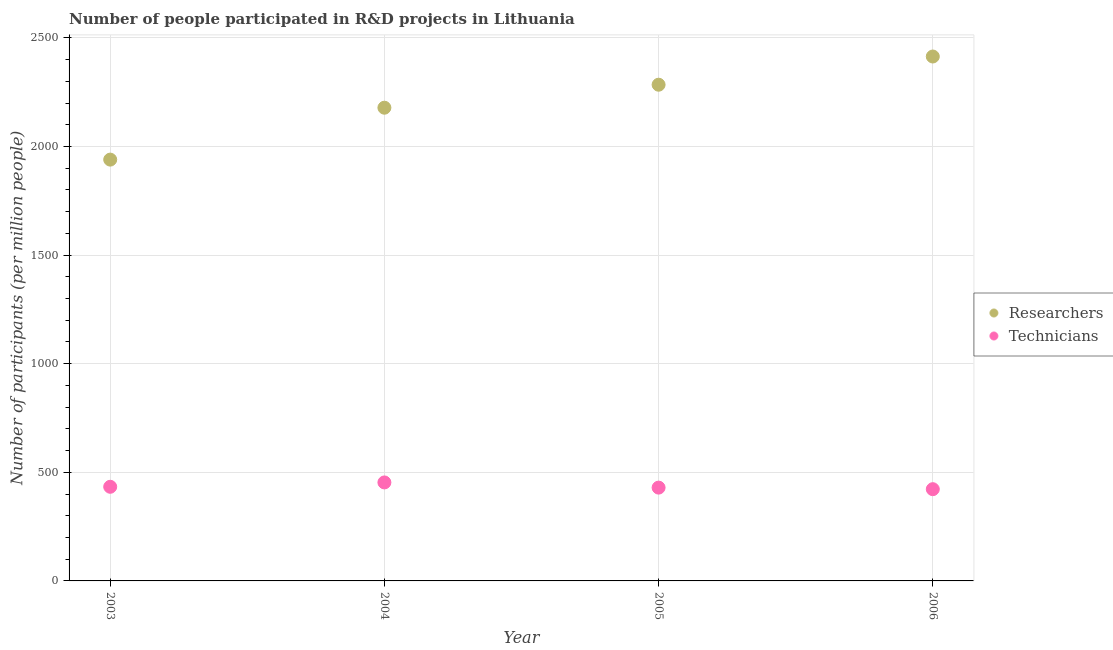How many different coloured dotlines are there?
Ensure brevity in your answer.  2. Is the number of dotlines equal to the number of legend labels?
Make the answer very short. Yes. What is the number of researchers in 2004?
Your answer should be compact. 2178.42. Across all years, what is the maximum number of technicians?
Provide a succinct answer. 453.39. Across all years, what is the minimum number of technicians?
Offer a terse response. 422.32. In which year was the number of technicians minimum?
Ensure brevity in your answer.  2006. What is the total number of technicians in the graph?
Offer a terse response. 1738.58. What is the difference between the number of technicians in 2004 and that in 2005?
Offer a terse response. 23.87. What is the difference between the number of technicians in 2006 and the number of researchers in 2005?
Your answer should be very brief. -1861.97. What is the average number of researchers per year?
Give a very brief answer. 2204.09. In the year 2006, what is the difference between the number of technicians and number of researchers?
Your answer should be very brief. -1991.81. What is the ratio of the number of researchers in 2003 to that in 2004?
Your answer should be very brief. 0.89. Is the number of technicians in 2004 less than that in 2006?
Offer a terse response. No. What is the difference between the highest and the second highest number of researchers?
Your response must be concise. 129.85. What is the difference between the highest and the lowest number of technicians?
Make the answer very short. 31.07. In how many years, is the number of researchers greater than the average number of researchers taken over all years?
Make the answer very short. 2. Is the sum of the number of technicians in 2003 and 2005 greater than the maximum number of researchers across all years?
Keep it short and to the point. No. Does the number of technicians monotonically increase over the years?
Ensure brevity in your answer.  No. Is the number of technicians strictly greater than the number of researchers over the years?
Offer a terse response. No. How many years are there in the graph?
Your response must be concise. 4. What is the difference between two consecutive major ticks on the Y-axis?
Provide a succinct answer. 500. Does the graph contain any zero values?
Your answer should be compact. No. Where does the legend appear in the graph?
Your answer should be very brief. Center right. What is the title of the graph?
Ensure brevity in your answer.  Number of people participated in R&D projects in Lithuania. Does "Diesel" appear as one of the legend labels in the graph?
Offer a terse response. No. What is the label or title of the X-axis?
Make the answer very short. Year. What is the label or title of the Y-axis?
Give a very brief answer. Number of participants (per million people). What is the Number of participants (per million people) in Researchers in 2003?
Your response must be concise. 1939.5. What is the Number of participants (per million people) in Technicians in 2003?
Make the answer very short. 433.35. What is the Number of participants (per million people) in Researchers in 2004?
Provide a short and direct response. 2178.42. What is the Number of participants (per million people) of Technicians in 2004?
Offer a very short reply. 453.39. What is the Number of participants (per million people) of Researchers in 2005?
Your answer should be very brief. 2284.29. What is the Number of participants (per million people) in Technicians in 2005?
Offer a very short reply. 429.52. What is the Number of participants (per million people) in Researchers in 2006?
Provide a short and direct response. 2414.14. What is the Number of participants (per million people) in Technicians in 2006?
Your response must be concise. 422.32. Across all years, what is the maximum Number of participants (per million people) in Researchers?
Provide a short and direct response. 2414.14. Across all years, what is the maximum Number of participants (per million people) in Technicians?
Your answer should be compact. 453.39. Across all years, what is the minimum Number of participants (per million people) in Researchers?
Provide a succinct answer. 1939.5. Across all years, what is the minimum Number of participants (per million people) of Technicians?
Provide a short and direct response. 422.32. What is the total Number of participants (per million people) in Researchers in the graph?
Your response must be concise. 8816.35. What is the total Number of participants (per million people) in Technicians in the graph?
Your answer should be compact. 1738.58. What is the difference between the Number of participants (per million people) of Researchers in 2003 and that in 2004?
Your response must be concise. -238.92. What is the difference between the Number of participants (per million people) in Technicians in 2003 and that in 2004?
Your answer should be very brief. -20.04. What is the difference between the Number of participants (per million people) in Researchers in 2003 and that in 2005?
Your response must be concise. -344.79. What is the difference between the Number of participants (per million people) of Technicians in 2003 and that in 2005?
Ensure brevity in your answer.  3.83. What is the difference between the Number of participants (per million people) in Researchers in 2003 and that in 2006?
Offer a terse response. -474.64. What is the difference between the Number of participants (per million people) in Technicians in 2003 and that in 2006?
Make the answer very short. 11.03. What is the difference between the Number of participants (per million people) of Researchers in 2004 and that in 2005?
Your response must be concise. -105.87. What is the difference between the Number of participants (per million people) in Technicians in 2004 and that in 2005?
Offer a very short reply. 23.87. What is the difference between the Number of participants (per million people) of Researchers in 2004 and that in 2006?
Keep it short and to the point. -235.72. What is the difference between the Number of participants (per million people) of Technicians in 2004 and that in 2006?
Make the answer very short. 31.07. What is the difference between the Number of participants (per million people) in Researchers in 2005 and that in 2006?
Offer a very short reply. -129.85. What is the difference between the Number of participants (per million people) in Technicians in 2005 and that in 2006?
Offer a very short reply. 7.2. What is the difference between the Number of participants (per million people) in Researchers in 2003 and the Number of participants (per million people) in Technicians in 2004?
Give a very brief answer. 1486.11. What is the difference between the Number of participants (per million people) in Researchers in 2003 and the Number of participants (per million people) in Technicians in 2005?
Offer a terse response. 1509.98. What is the difference between the Number of participants (per million people) in Researchers in 2003 and the Number of participants (per million people) in Technicians in 2006?
Offer a very short reply. 1517.18. What is the difference between the Number of participants (per million people) in Researchers in 2004 and the Number of participants (per million people) in Technicians in 2005?
Give a very brief answer. 1748.9. What is the difference between the Number of participants (per million people) of Researchers in 2004 and the Number of participants (per million people) of Technicians in 2006?
Offer a terse response. 1756.1. What is the difference between the Number of participants (per million people) of Researchers in 2005 and the Number of participants (per million people) of Technicians in 2006?
Ensure brevity in your answer.  1861.97. What is the average Number of participants (per million people) of Researchers per year?
Offer a very short reply. 2204.09. What is the average Number of participants (per million people) of Technicians per year?
Provide a succinct answer. 434.65. In the year 2003, what is the difference between the Number of participants (per million people) in Researchers and Number of participants (per million people) in Technicians?
Provide a succinct answer. 1506.15. In the year 2004, what is the difference between the Number of participants (per million people) in Researchers and Number of participants (per million people) in Technicians?
Offer a very short reply. 1725.03. In the year 2005, what is the difference between the Number of participants (per million people) of Researchers and Number of participants (per million people) of Technicians?
Your answer should be very brief. 1854.77. In the year 2006, what is the difference between the Number of participants (per million people) of Researchers and Number of participants (per million people) of Technicians?
Your answer should be compact. 1991.81. What is the ratio of the Number of participants (per million people) in Researchers in 2003 to that in 2004?
Ensure brevity in your answer.  0.89. What is the ratio of the Number of participants (per million people) of Technicians in 2003 to that in 2004?
Ensure brevity in your answer.  0.96. What is the ratio of the Number of participants (per million people) of Researchers in 2003 to that in 2005?
Provide a short and direct response. 0.85. What is the ratio of the Number of participants (per million people) in Technicians in 2003 to that in 2005?
Ensure brevity in your answer.  1.01. What is the ratio of the Number of participants (per million people) of Researchers in 2003 to that in 2006?
Keep it short and to the point. 0.8. What is the ratio of the Number of participants (per million people) of Technicians in 2003 to that in 2006?
Offer a terse response. 1.03. What is the ratio of the Number of participants (per million people) in Researchers in 2004 to that in 2005?
Your response must be concise. 0.95. What is the ratio of the Number of participants (per million people) in Technicians in 2004 to that in 2005?
Your response must be concise. 1.06. What is the ratio of the Number of participants (per million people) of Researchers in 2004 to that in 2006?
Offer a terse response. 0.9. What is the ratio of the Number of participants (per million people) in Technicians in 2004 to that in 2006?
Ensure brevity in your answer.  1.07. What is the ratio of the Number of participants (per million people) in Researchers in 2005 to that in 2006?
Give a very brief answer. 0.95. What is the difference between the highest and the second highest Number of participants (per million people) in Researchers?
Offer a terse response. 129.85. What is the difference between the highest and the second highest Number of participants (per million people) of Technicians?
Offer a terse response. 20.04. What is the difference between the highest and the lowest Number of participants (per million people) in Researchers?
Offer a very short reply. 474.64. What is the difference between the highest and the lowest Number of participants (per million people) of Technicians?
Offer a terse response. 31.07. 